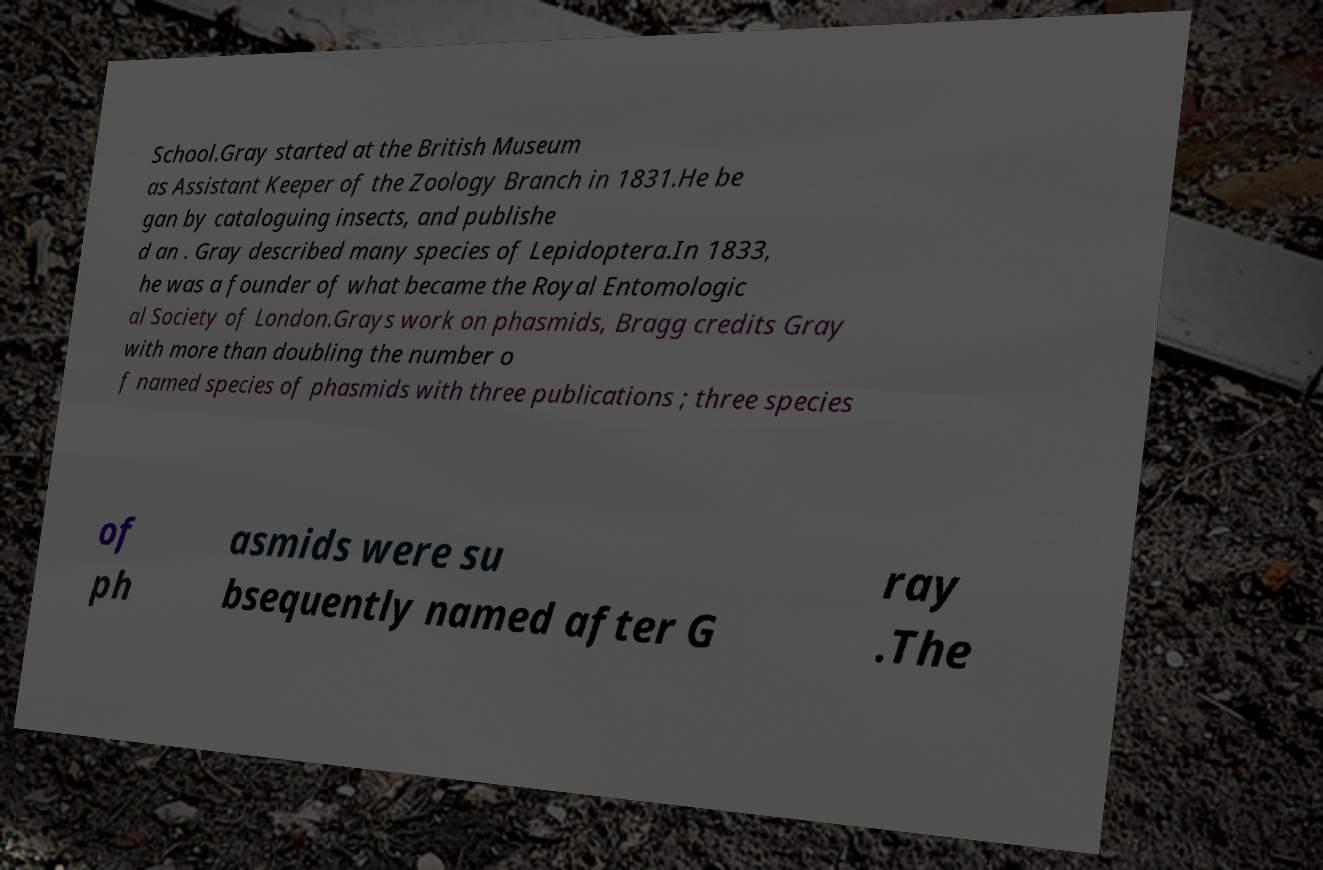I need the written content from this picture converted into text. Can you do that? School.Gray started at the British Museum as Assistant Keeper of the Zoology Branch in 1831.He be gan by cataloguing insects, and publishe d an . Gray described many species of Lepidoptera.In 1833, he was a founder of what became the Royal Entomologic al Society of London.Grays work on phasmids, Bragg credits Gray with more than doubling the number o f named species of phasmids with three publications ; three species of ph asmids were su bsequently named after G ray .The 